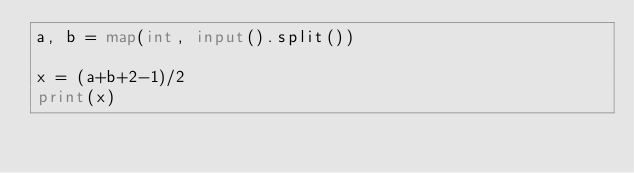<code> <loc_0><loc_0><loc_500><loc_500><_Python_>a, b = map(int, input().split())

x = (a+b+2-1)/2
print(x)</code> 